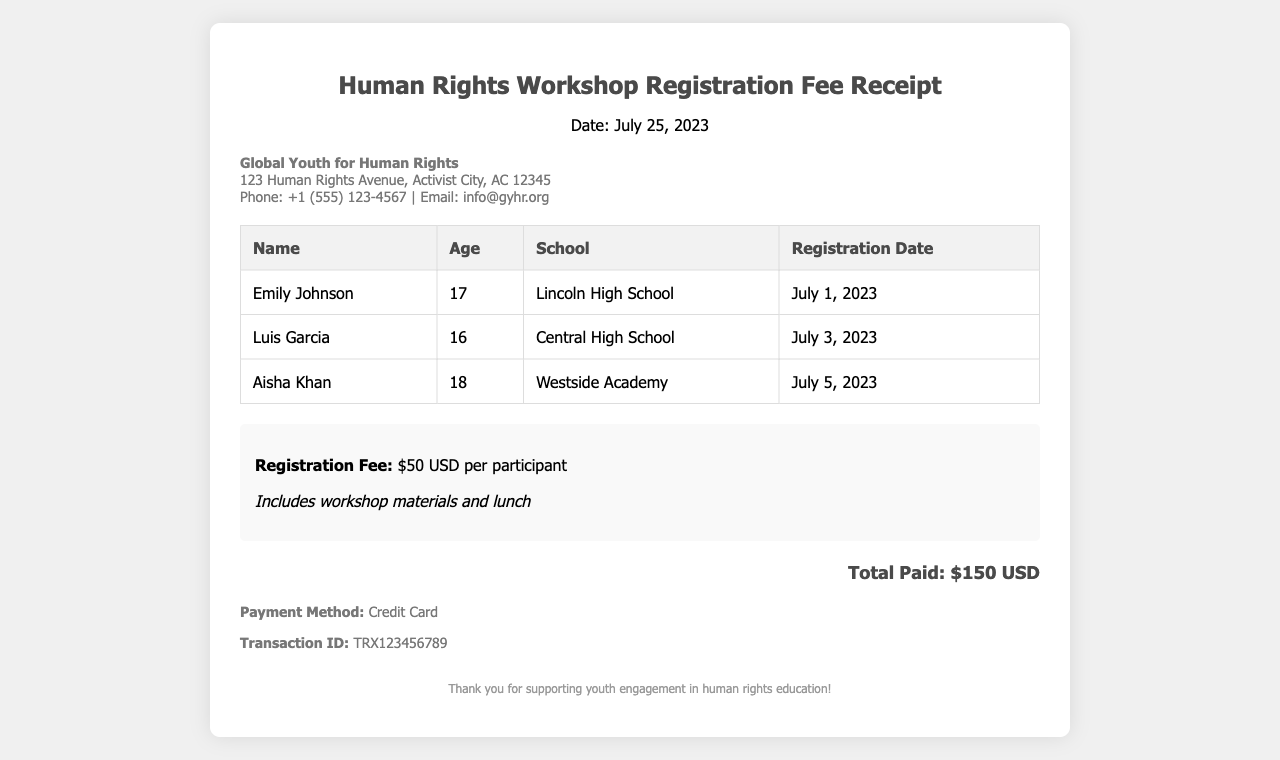What is the date of the receipt? The receipt is dated July 25, 2023, as indicated in the header section.
Answer: July 25, 2023 Who is the organization issuing the receipt? The organization’s name is Global Youth for Human Rights, found in the organization details section.
Answer: Global Youth for Human Rights What is the total amount paid? The total amount paid is stated as $150 USD in the total section of the receipt.
Answer: $150 USD How many participants registered for the workshop? There are three participants listed in the participant table of the document.
Answer: 3 What is the registration fee per participant? The registration fee is noted as $50 USD per participant in the fee details section.
Answer: $50 USD What was the last registration date? Aisha Khan registered on July 5, 2023, which is the last date mentioned in the participant table.
Answer: July 5, 2023 What payment method was used? The payment method is described as Credit Card in the payment information section.
Answer: Credit Card What is the transaction ID for the payment? The transaction ID is listed as TRX123456789 in the payment information section.
Answer: TRX123456789 Which school does Emily Johnson attend? The school of Emily Johnson is mentioned as Lincoln High School in the participant table.
Answer: Lincoln High School 